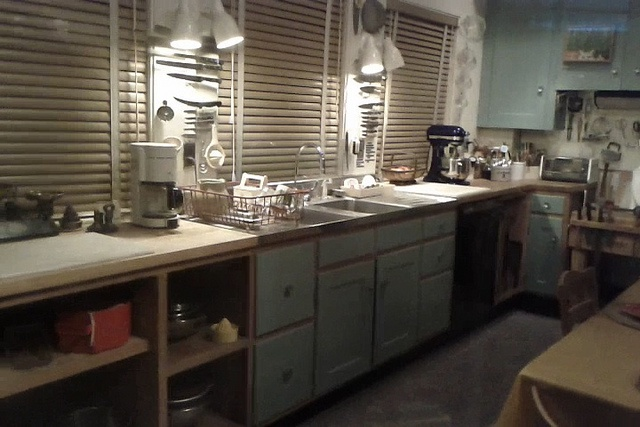Describe the objects in this image and their specific colors. I can see dining table in gray and black tones, chair in gray and black tones, microwave in gray and black tones, sink in gray, darkgray, black, and lightgray tones, and bowl in gray, tan, and maroon tones in this image. 